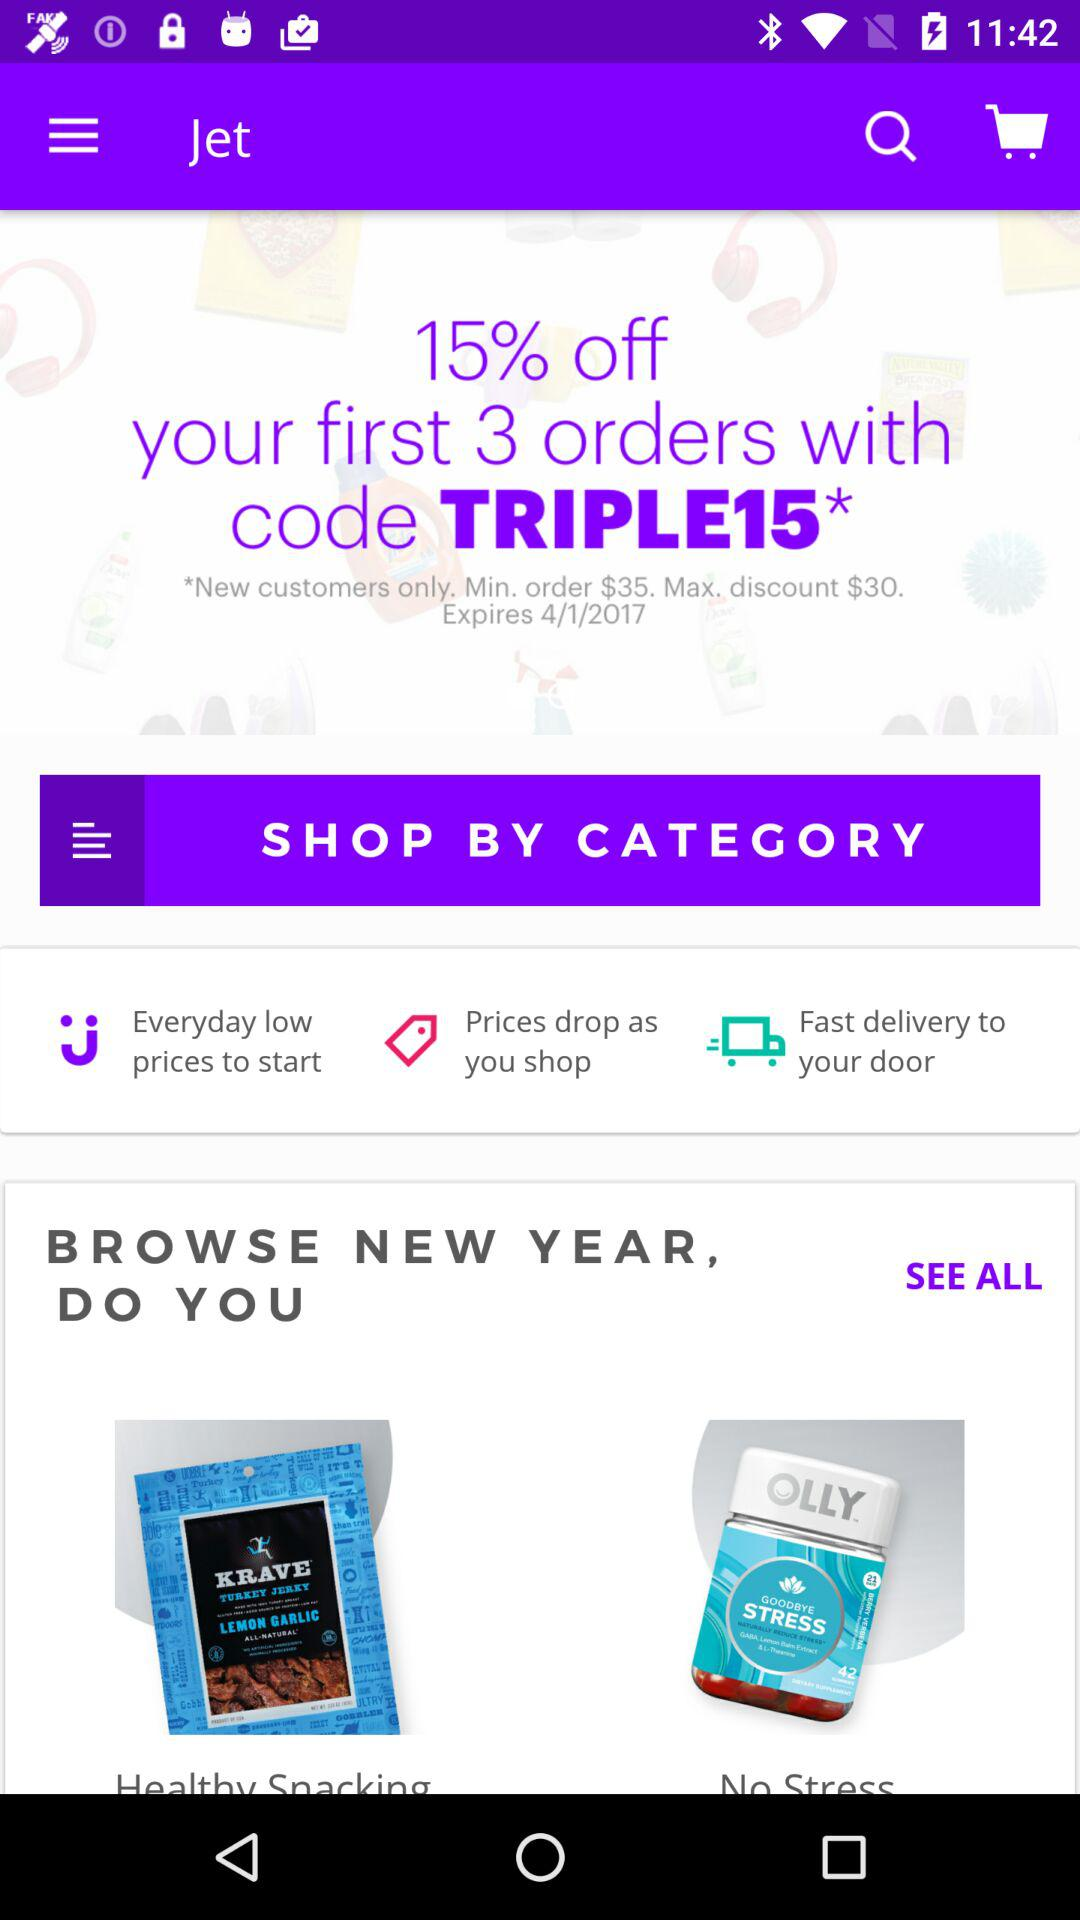What is the minimum order amount? The minimum order amount is $35. 